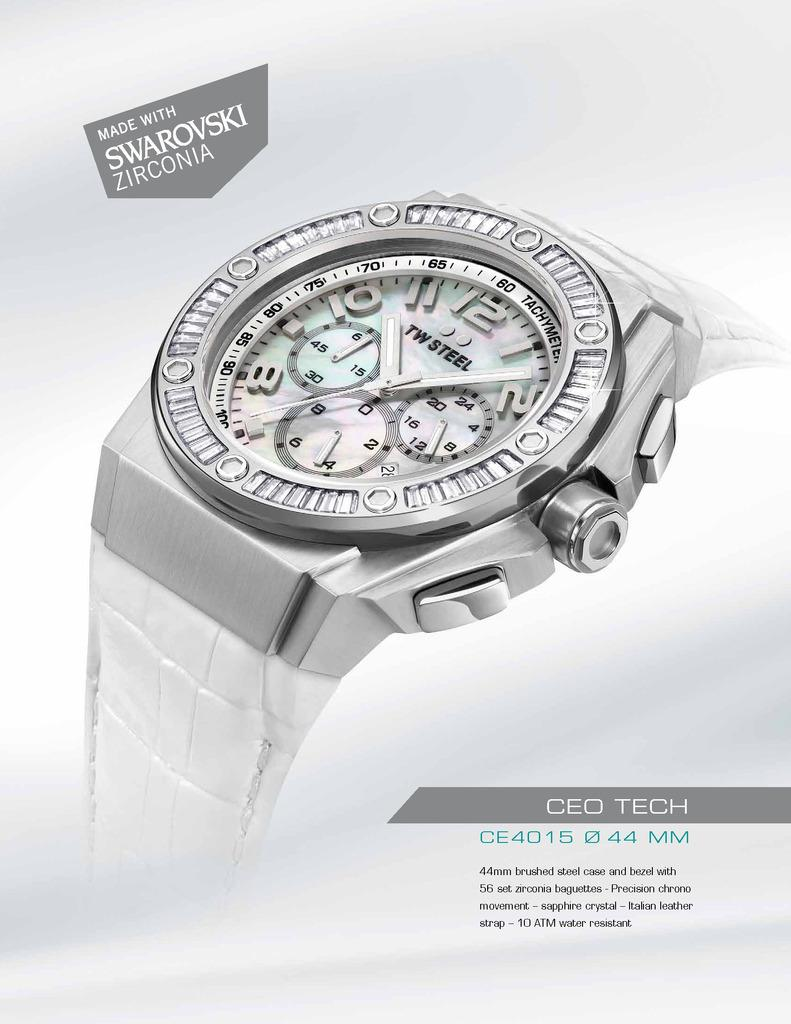<image>
Share a concise interpretation of the image provided. An advertisement for a watch that is made with Swarovski Zirconia. 